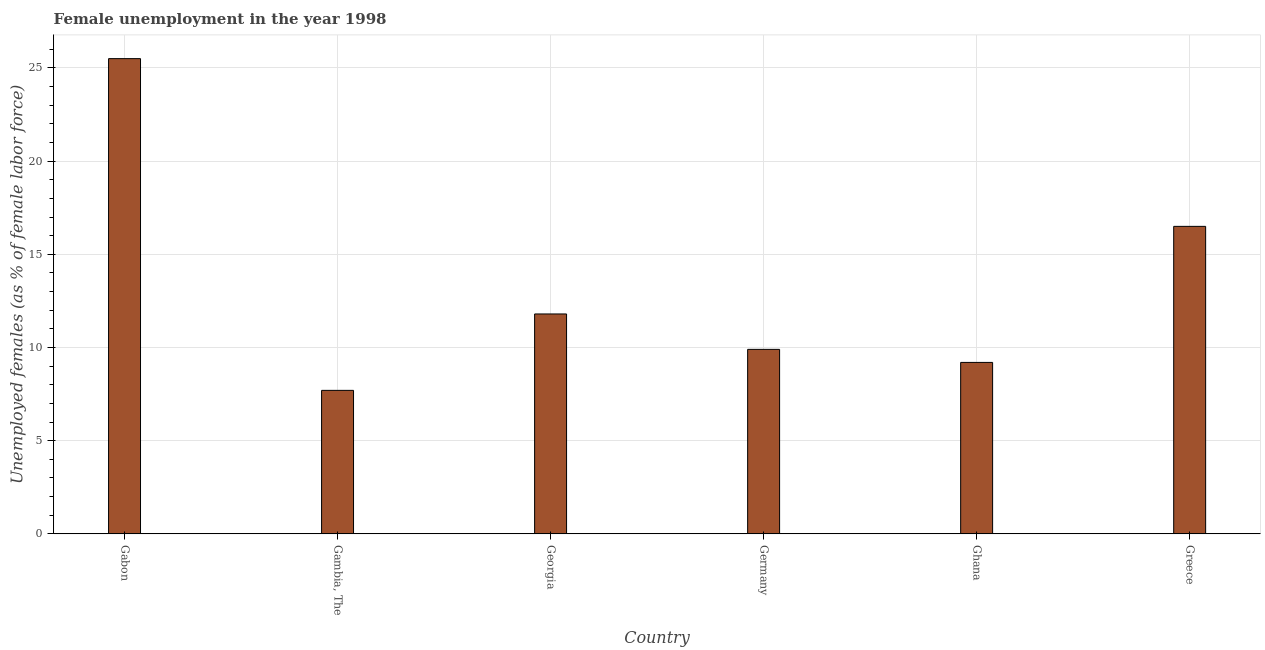Does the graph contain any zero values?
Offer a terse response. No. Does the graph contain grids?
Your response must be concise. Yes. What is the title of the graph?
Your answer should be compact. Female unemployment in the year 1998. What is the label or title of the X-axis?
Your answer should be compact. Country. What is the label or title of the Y-axis?
Provide a short and direct response. Unemployed females (as % of female labor force). What is the unemployed females population in Gambia, The?
Provide a succinct answer. 7.7. Across all countries, what is the minimum unemployed females population?
Make the answer very short. 7.7. In which country was the unemployed females population maximum?
Your answer should be compact. Gabon. In which country was the unemployed females population minimum?
Provide a short and direct response. Gambia, The. What is the sum of the unemployed females population?
Keep it short and to the point. 80.6. What is the average unemployed females population per country?
Give a very brief answer. 13.43. What is the median unemployed females population?
Make the answer very short. 10.85. In how many countries, is the unemployed females population greater than 25 %?
Your answer should be very brief. 1. Is the difference between the unemployed females population in Gabon and Greece greater than the difference between any two countries?
Provide a short and direct response. No. What is the difference between the highest and the second highest unemployed females population?
Your response must be concise. 9. What is the difference between the highest and the lowest unemployed females population?
Keep it short and to the point. 17.8. How many countries are there in the graph?
Ensure brevity in your answer.  6. What is the difference between two consecutive major ticks on the Y-axis?
Offer a very short reply. 5. What is the Unemployed females (as % of female labor force) in Gambia, The?
Your answer should be very brief. 7.7. What is the Unemployed females (as % of female labor force) of Georgia?
Your response must be concise. 11.8. What is the Unemployed females (as % of female labor force) of Germany?
Keep it short and to the point. 9.9. What is the Unemployed females (as % of female labor force) in Ghana?
Your answer should be compact. 9.2. What is the Unemployed females (as % of female labor force) in Greece?
Make the answer very short. 16.5. What is the difference between the Unemployed females (as % of female labor force) in Gabon and Georgia?
Offer a very short reply. 13.7. What is the difference between the Unemployed females (as % of female labor force) in Gabon and Germany?
Offer a terse response. 15.6. What is the difference between the Unemployed females (as % of female labor force) in Gabon and Greece?
Give a very brief answer. 9. What is the difference between the Unemployed females (as % of female labor force) in Georgia and Ghana?
Your answer should be very brief. 2.6. What is the difference between the Unemployed females (as % of female labor force) in Germany and Greece?
Your response must be concise. -6.6. What is the ratio of the Unemployed females (as % of female labor force) in Gabon to that in Gambia, The?
Offer a very short reply. 3.31. What is the ratio of the Unemployed females (as % of female labor force) in Gabon to that in Georgia?
Provide a succinct answer. 2.16. What is the ratio of the Unemployed females (as % of female labor force) in Gabon to that in Germany?
Your answer should be very brief. 2.58. What is the ratio of the Unemployed females (as % of female labor force) in Gabon to that in Ghana?
Provide a short and direct response. 2.77. What is the ratio of the Unemployed females (as % of female labor force) in Gabon to that in Greece?
Your response must be concise. 1.54. What is the ratio of the Unemployed females (as % of female labor force) in Gambia, The to that in Georgia?
Provide a short and direct response. 0.65. What is the ratio of the Unemployed females (as % of female labor force) in Gambia, The to that in Germany?
Make the answer very short. 0.78. What is the ratio of the Unemployed females (as % of female labor force) in Gambia, The to that in Ghana?
Offer a terse response. 0.84. What is the ratio of the Unemployed females (as % of female labor force) in Gambia, The to that in Greece?
Your answer should be compact. 0.47. What is the ratio of the Unemployed females (as % of female labor force) in Georgia to that in Germany?
Offer a very short reply. 1.19. What is the ratio of the Unemployed females (as % of female labor force) in Georgia to that in Ghana?
Your response must be concise. 1.28. What is the ratio of the Unemployed females (as % of female labor force) in Georgia to that in Greece?
Provide a short and direct response. 0.71. What is the ratio of the Unemployed females (as % of female labor force) in Germany to that in Ghana?
Provide a succinct answer. 1.08. What is the ratio of the Unemployed females (as % of female labor force) in Germany to that in Greece?
Your answer should be compact. 0.6. What is the ratio of the Unemployed females (as % of female labor force) in Ghana to that in Greece?
Provide a short and direct response. 0.56. 